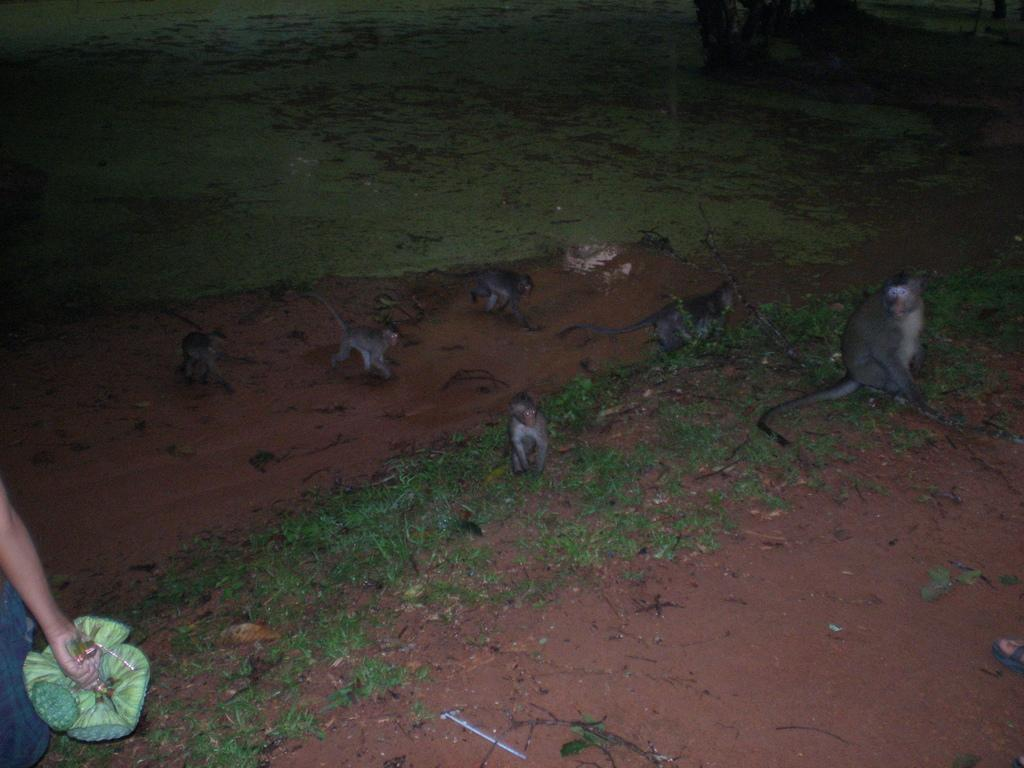What animals are present in the image? There are monkeys in the image. What are the monkeys doing in the image? The monkeys are sitting and walking on the grass. Can you describe the person on the left side of the image? There is a person on the left side of the image, and he is holding something in his hand. What type of coat is the mother wearing in the image? There is no mother or coat present in the image. 